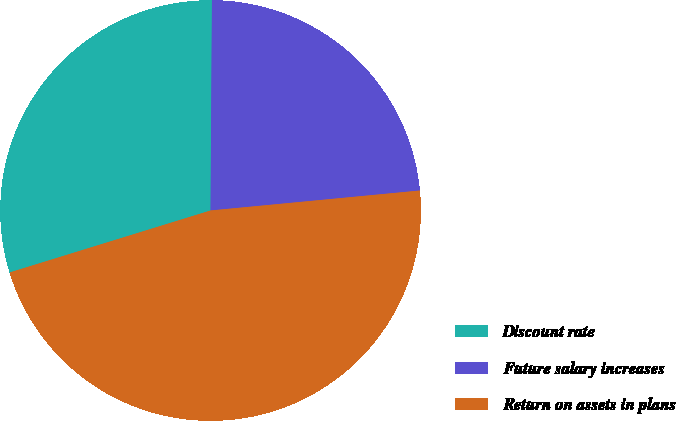Convert chart. <chart><loc_0><loc_0><loc_500><loc_500><pie_chart><fcel>Discount rate<fcel>Future salary increases<fcel>Return on assets in plans<nl><fcel>29.87%<fcel>23.38%<fcel>46.75%<nl></chart> 